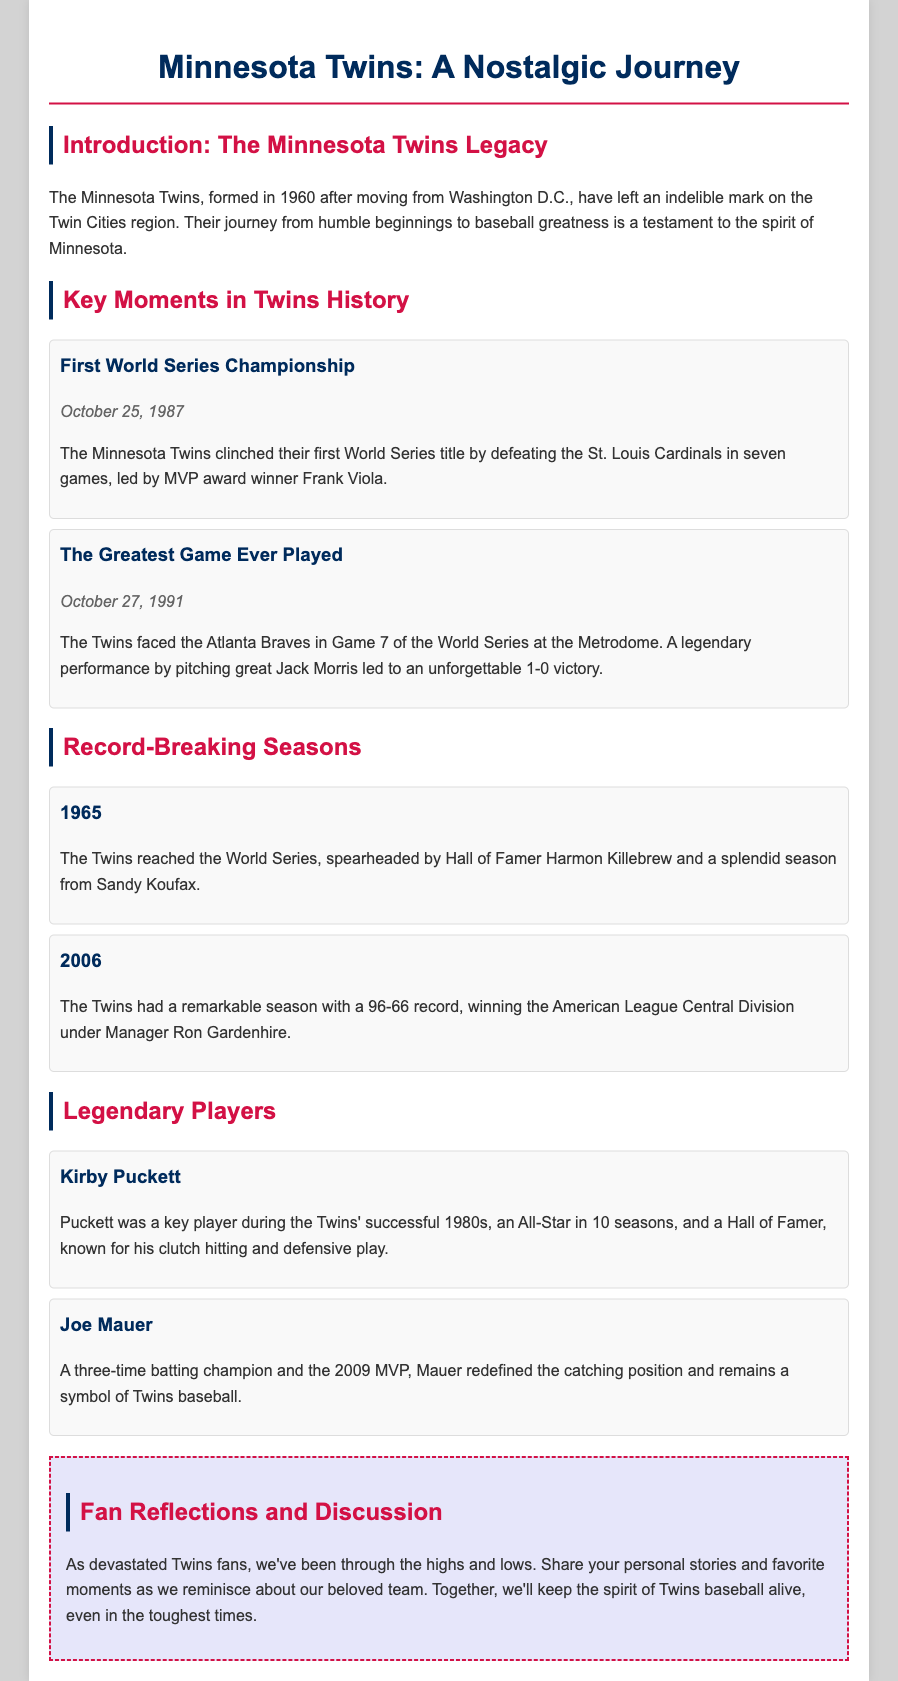What year did the Twins win their first World Series? The event describes the first World Series championship by the Twins, which occurred on October 25, 1987.
Answer: 1987 Who was the MVP in the first World Series championship? The document states that Frank Viola was the MVP award winner during the first World Series title.
Answer: Frank Viola What was the score of the greatest game ever played? The document indicates that the Twins won the game with a score of 1-0 against the Atlanta Braves.
Answer: 1-0 In what year did the Twins reach the World Series with Harmon Killebrew? The season highlights that the Twins reached the World Series in 1965 with Harmon Killebrew.
Answer: 1965 How many American League Central Division titles did the Twins win in 2006? The document mentions that the Twins had a 96-66 record in 2006 and won the division.
Answer: One Which player was a key figure in the Twins' success during the 1980s? The document describes Kirby Puckett as a key player during the Twins' successful 1980s.
Answer: Kirby Puckett How many batting championships did Joe Mauer win? The document notes that Joe Mauer is a three-time batting champion.
Answer: Three What is the purpose of the 'Fan Reflections and Discussion' section? The section invites fans to share personal stories and favorite moments reminiscing about the team.
Answer: Share personal stories What color is used for the document's title? The title in the document is styled with a color code that corresponds to a specific shade.
Answer: #002B5C 